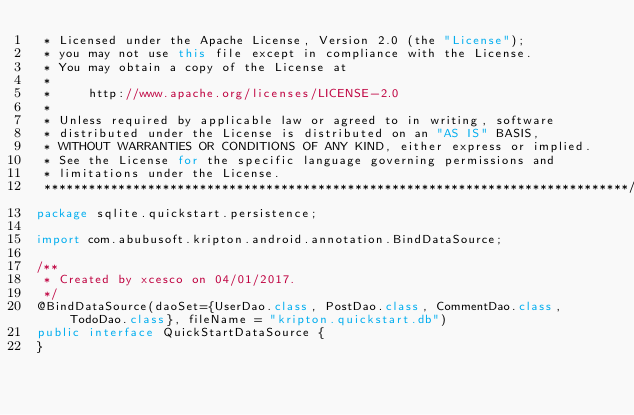<code> <loc_0><loc_0><loc_500><loc_500><_Java_> * Licensed under the Apache License, Version 2.0 (the "License");
 * you may not use this file except in compliance with the License.
 * You may obtain a copy of the License at
 *
 *     http://www.apache.org/licenses/LICENSE-2.0
 *
 * Unless required by applicable law or agreed to in writing, software
 * distributed under the License is distributed on an "AS IS" BASIS,
 * WITHOUT WARRANTIES OR CONDITIONS OF ANY KIND, either express or implied.
 * See the License for the specific language governing permissions and
 * limitations under the License.
 *******************************************************************************/
package sqlite.quickstart.persistence;

import com.abubusoft.kripton.android.annotation.BindDataSource;

/**
 * Created by xcesco on 04/01/2017.
 */
@BindDataSource(daoSet={UserDao.class, PostDao.class, CommentDao.class, TodoDao.class}, fileName = "kripton.quickstart.db")
public interface QuickStartDataSource {
}
</code> 